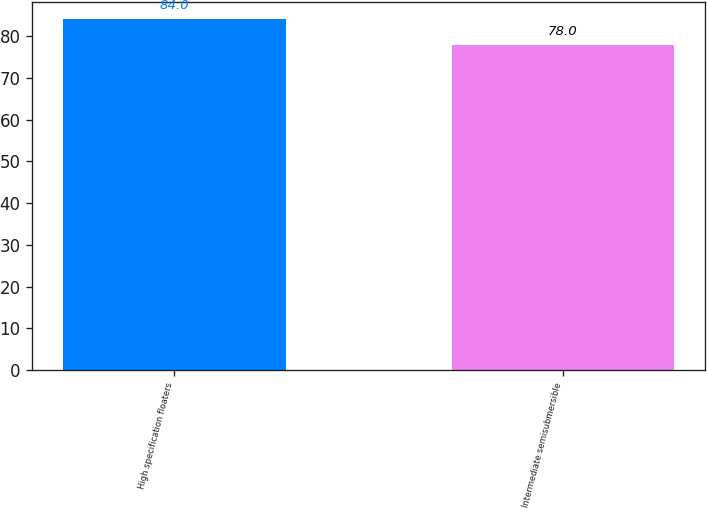<chart> <loc_0><loc_0><loc_500><loc_500><bar_chart><fcel>High specification floaters<fcel>Intermediate semisubmersible<nl><fcel>84<fcel>78<nl></chart> 